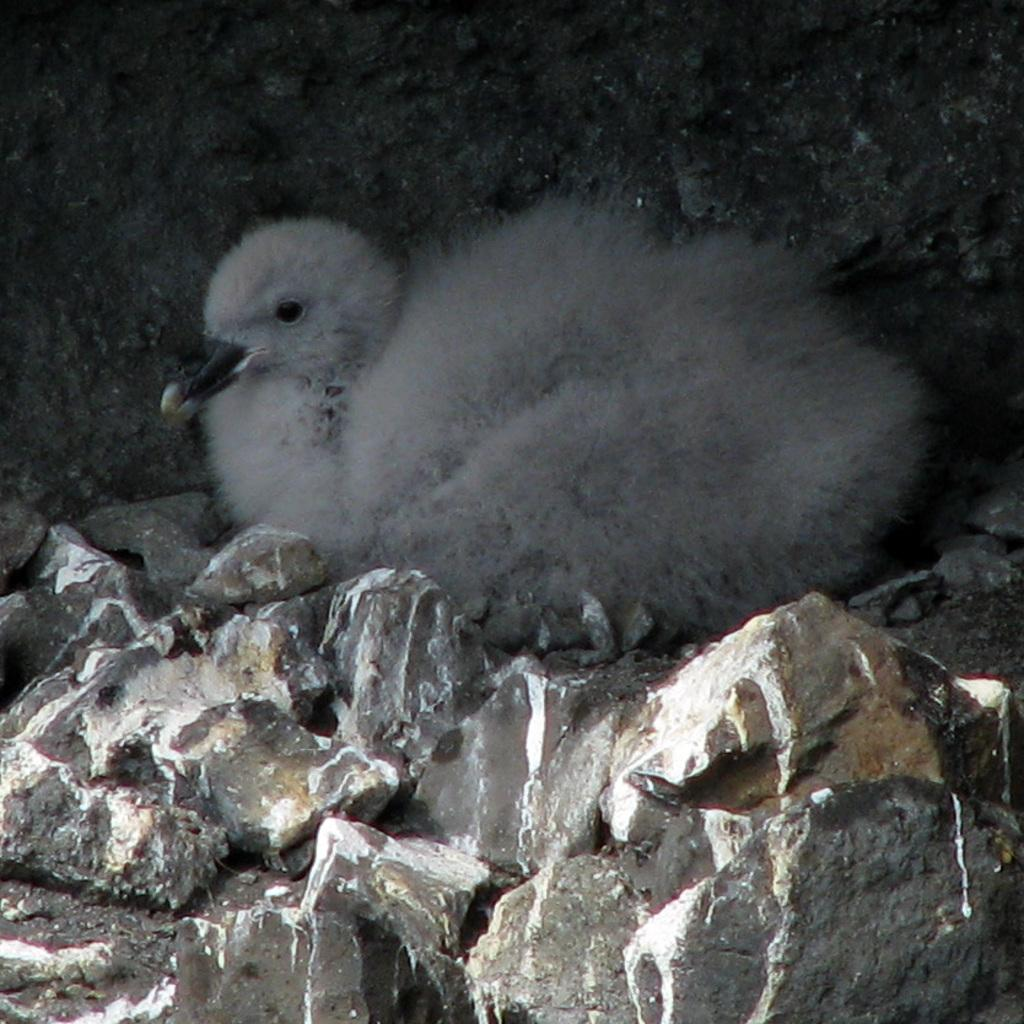Where was the image taken? The image was taken outdoors. What can be seen in the background of the image? There is a rock in the background of the image. Are there any rocks visible at the bottom of the image? Yes, there are a few rocks at the bottom of the image. What is the main subject in the middle of the image? There is a bird in the middle of the image. What type of coil is being used by the bird in the image? There is no coil present in the image; it features a bird in the middle of the scene. 